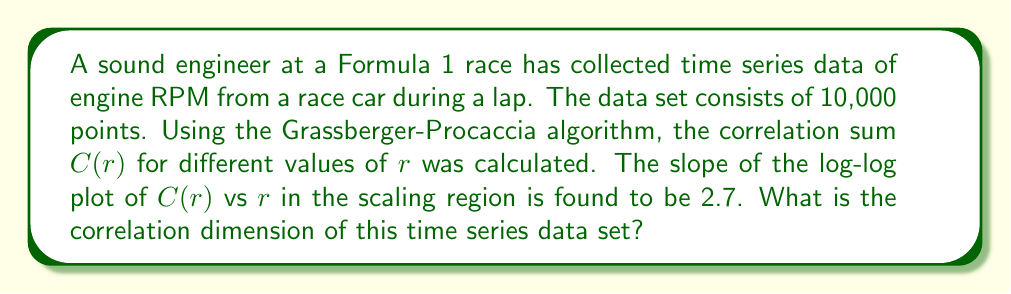Solve this math problem. To compute the correlation dimension of a time series data set, we follow these steps:

1) The Grassberger-Procaccia algorithm is used to calculate the correlation sum $C(r)$ for different values of $r$, where $r$ is the radius of hyperspheres centered on each point in the phase space.

2) The correlation sum $C(r)$ is defined as:

   $$C(r) = \frac{2}{N(N-1)} \sum_{i=1}^{N} \sum_{j=i+1}^{N} \Theta(r - ||x_i - x_j||)$$

   where $N$ is the number of points, $\Theta$ is the Heaviside step function, and $||x_i - x_j||$ is the distance between points $i$ and $j$.

3) For small $r$, $C(r)$ scales as a power law:

   $$C(r) \propto r^D$$

   where $D$ is the correlation dimension.

4) Taking logarithms of both sides:

   $$\log(C(r)) \propto D \log(r)$$

5) This relationship is linear in log-log space, with $D$ as the slope.

6) In this case, we're given that the slope of the log-log plot of $C(r)$ vs $r$ in the scaling region is 2.7.

7) Therefore, the correlation dimension $D$ is equal to this slope, 2.7.

This non-integer dimension suggests that the engine RPM time series has fractal characteristics, which is typical for complex dynamical systems like race car engines.
Answer: 2.7 